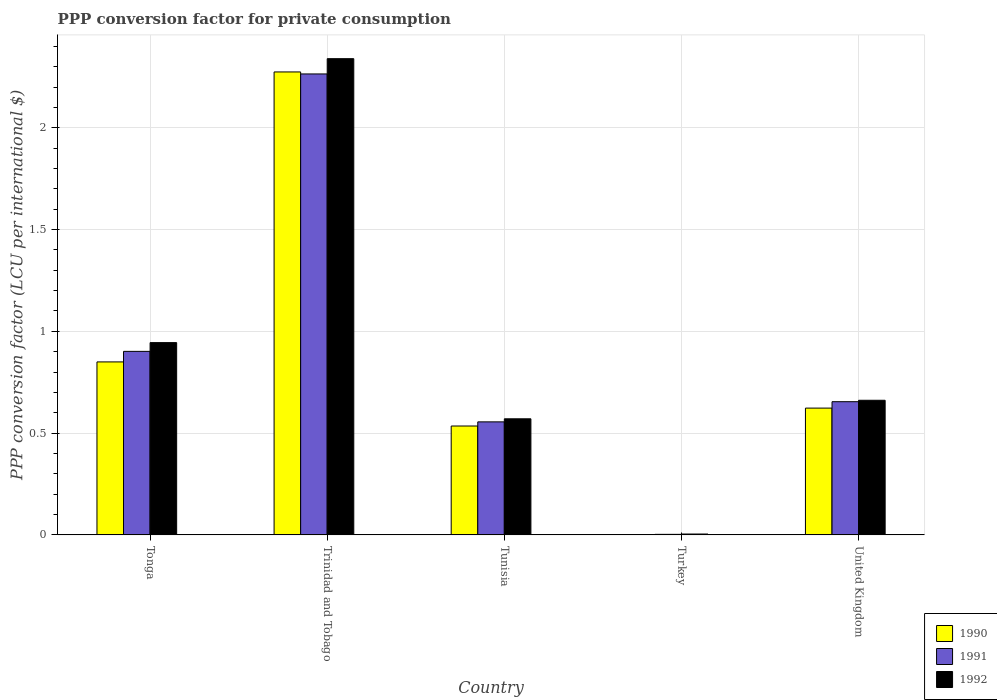How many groups of bars are there?
Your response must be concise. 5. Are the number of bars per tick equal to the number of legend labels?
Ensure brevity in your answer.  Yes. How many bars are there on the 3rd tick from the right?
Your answer should be very brief. 3. What is the label of the 2nd group of bars from the left?
Offer a very short reply. Trinidad and Tobago. In how many cases, is the number of bars for a given country not equal to the number of legend labels?
Offer a very short reply. 0. What is the PPP conversion factor for private consumption in 1991 in Trinidad and Tobago?
Make the answer very short. 2.26. Across all countries, what is the maximum PPP conversion factor for private consumption in 1990?
Your answer should be very brief. 2.27. Across all countries, what is the minimum PPP conversion factor for private consumption in 1990?
Offer a very short reply. 0. In which country was the PPP conversion factor for private consumption in 1992 maximum?
Your answer should be very brief. Trinidad and Tobago. What is the total PPP conversion factor for private consumption in 1991 in the graph?
Your response must be concise. 4.38. What is the difference between the PPP conversion factor for private consumption in 1991 in Tunisia and that in United Kingdom?
Your response must be concise. -0.1. What is the difference between the PPP conversion factor for private consumption in 1992 in United Kingdom and the PPP conversion factor for private consumption in 1991 in Trinidad and Tobago?
Make the answer very short. -1.6. What is the average PPP conversion factor for private consumption in 1992 per country?
Offer a terse response. 0.9. What is the difference between the PPP conversion factor for private consumption of/in 1990 and PPP conversion factor for private consumption of/in 1992 in Turkey?
Offer a very short reply. -0. What is the ratio of the PPP conversion factor for private consumption in 1990 in Trinidad and Tobago to that in Tunisia?
Offer a terse response. 4.25. What is the difference between the highest and the second highest PPP conversion factor for private consumption in 1992?
Give a very brief answer. 0.28. What is the difference between the highest and the lowest PPP conversion factor for private consumption in 1990?
Offer a terse response. 2.27. What does the 1st bar from the right in Trinidad and Tobago represents?
Offer a terse response. 1992. Is it the case that in every country, the sum of the PPP conversion factor for private consumption in 1991 and PPP conversion factor for private consumption in 1990 is greater than the PPP conversion factor for private consumption in 1992?
Keep it short and to the point. Yes. How many bars are there?
Offer a very short reply. 15. Does the graph contain any zero values?
Make the answer very short. No. Does the graph contain grids?
Offer a very short reply. Yes. How are the legend labels stacked?
Ensure brevity in your answer.  Vertical. What is the title of the graph?
Your response must be concise. PPP conversion factor for private consumption. Does "1970" appear as one of the legend labels in the graph?
Provide a succinct answer. No. What is the label or title of the Y-axis?
Keep it short and to the point. PPP conversion factor (LCU per international $). What is the PPP conversion factor (LCU per international $) in 1990 in Tonga?
Your response must be concise. 0.85. What is the PPP conversion factor (LCU per international $) in 1991 in Tonga?
Offer a terse response. 0.9. What is the PPP conversion factor (LCU per international $) of 1992 in Tonga?
Your answer should be compact. 0.94. What is the PPP conversion factor (LCU per international $) in 1990 in Trinidad and Tobago?
Give a very brief answer. 2.27. What is the PPP conversion factor (LCU per international $) in 1991 in Trinidad and Tobago?
Provide a succinct answer. 2.26. What is the PPP conversion factor (LCU per international $) in 1992 in Trinidad and Tobago?
Your answer should be very brief. 2.34. What is the PPP conversion factor (LCU per international $) of 1990 in Tunisia?
Make the answer very short. 0.53. What is the PPP conversion factor (LCU per international $) of 1991 in Tunisia?
Offer a terse response. 0.56. What is the PPP conversion factor (LCU per international $) of 1992 in Tunisia?
Provide a succinct answer. 0.57. What is the PPP conversion factor (LCU per international $) in 1990 in Turkey?
Offer a very short reply. 0. What is the PPP conversion factor (LCU per international $) in 1991 in Turkey?
Offer a very short reply. 0. What is the PPP conversion factor (LCU per international $) of 1992 in Turkey?
Offer a very short reply. 0. What is the PPP conversion factor (LCU per international $) of 1990 in United Kingdom?
Offer a terse response. 0.62. What is the PPP conversion factor (LCU per international $) of 1991 in United Kingdom?
Offer a terse response. 0.65. What is the PPP conversion factor (LCU per international $) in 1992 in United Kingdom?
Ensure brevity in your answer.  0.66. Across all countries, what is the maximum PPP conversion factor (LCU per international $) in 1990?
Your answer should be very brief. 2.27. Across all countries, what is the maximum PPP conversion factor (LCU per international $) of 1991?
Ensure brevity in your answer.  2.26. Across all countries, what is the maximum PPP conversion factor (LCU per international $) of 1992?
Provide a short and direct response. 2.34. Across all countries, what is the minimum PPP conversion factor (LCU per international $) of 1990?
Offer a very short reply. 0. Across all countries, what is the minimum PPP conversion factor (LCU per international $) of 1991?
Your answer should be compact. 0. Across all countries, what is the minimum PPP conversion factor (LCU per international $) of 1992?
Provide a short and direct response. 0. What is the total PPP conversion factor (LCU per international $) of 1990 in the graph?
Provide a short and direct response. 4.28. What is the total PPP conversion factor (LCU per international $) of 1991 in the graph?
Keep it short and to the point. 4.38. What is the total PPP conversion factor (LCU per international $) in 1992 in the graph?
Your answer should be very brief. 4.52. What is the difference between the PPP conversion factor (LCU per international $) in 1990 in Tonga and that in Trinidad and Tobago?
Offer a very short reply. -1.42. What is the difference between the PPP conversion factor (LCU per international $) in 1991 in Tonga and that in Trinidad and Tobago?
Provide a succinct answer. -1.36. What is the difference between the PPP conversion factor (LCU per international $) of 1992 in Tonga and that in Trinidad and Tobago?
Provide a succinct answer. -1.39. What is the difference between the PPP conversion factor (LCU per international $) in 1990 in Tonga and that in Tunisia?
Provide a succinct answer. 0.31. What is the difference between the PPP conversion factor (LCU per international $) of 1991 in Tonga and that in Tunisia?
Make the answer very short. 0.35. What is the difference between the PPP conversion factor (LCU per international $) in 1992 in Tonga and that in Tunisia?
Offer a very short reply. 0.37. What is the difference between the PPP conversion factor (LCU per international $) in 1990 in Tonga and that in Turkey?
Provide a short and direct response. 0.85. What is the difference between the PPP conversion factor (LCU per international $) in 1991 in Tonga and that in Turkey?
Your response must be concise. 0.9. What is the difference between the PPP conversion factor (LCU per international $) in 1992 in Tonga and that in Turkey?
Offer a very short reply. 0.94. What is the difference between the PPP conversion factor (LCU per international $) of 1990 in Tonga and that in United Kingdom?
Offer a very short reply. 0.23. What is the difference between the PPP conversion factor (LCU per international $) in 1991 in Tonga and that in United Kingdom?
Make the answer very short. 0.25. What is the difference between the PPP conversion factor (LCU per international $) of 1992 in Tonga and that in United Kingdom?
Make the answer very short. 0.28. What is the difference between the PPP conversion factor (LCU per international $) in 1990 in Trinidad and Tobago and that in Tunisia?
Provide a short and direct response. 1.74. What is the difference between the PPP conversion factor (LCU per international $) in 1991 in Trinidad and Tobago and that in Tunisia?
Your answer should be very brief. 1.71. What is the difference between the PPP conversion factor (LCU per international $) in 1992 in Trinidad and Tobago and that in Tunisia?
Ensure brevity in your answer.  1.77. What is the difference between the PPP conversion factor (LCU per international $) in 1990 in Trinidad and Tobago and that in Turkey?
Keep it short and to the point. 2.27. What is the difference between the PPP conversion factor (LCU per international $) of 1991 in Trinidad and Tobago and that in Turkey?
Ensure brevity in your answer.  2.26. What is the difference between the PPP conversion factor (LCU per international $) in 1992 in Trinidad and Tobago and that in Turkey?
Provide a succinct answer. 2.33. What is the difference between the PPP conversion factor (LCU per international $) in 1990 in Trinidad and Tobago and that in United Kingdom?
Provide a succinct answer. 1.65. What is the difference between the PPP conversion factor (LCU per international $) of 1991 in Trinidad and Tobago and that in United Kingdom?
Ensure brevity in your answer.  1.61. What is the difference between the PPP conversion factor (LCU per international $) of 1992 in Trinidad and Tobago and that in United Kingdom?
Keep it short and to the point. 1.68. What is the difference between the PPP conversion factor (LCU per international $) in 1990 in Tunisia and that in Turkey?
Your response must be concise. 0.53. What is the difference between the PPP conversion factor (LCU per international $) of 1991 in Tunisia and that in Turkey?
Make the answer very short. 0.55. What is the difference between the PPP conversion factor (LCU per international $) of 1992 in Tunisia and that in Turkey?
Ensure brevity in your answer.  0.57. What is the difference between the PPP conversion factor (LCU per international $) of 1990 in Tunisia and that in United Kingdom?
Provide a succinct answer. -0.09. What is the difference between the PPP conversion factor (LCU per international $) of 1991 in Tunisia and that in United Kingdom?
Provide a succinct answer. -0.1. What is the difference between the PPP conversion factor (LCU per international $) of 1992 in Tunisia and that in United Kingdom?
Provide a short and direct response. -0.09. What is the difference between the PPP conversion factor (LCU per international $) in 1990 in Turkey and that in United Kingdom?
Give a very brief answer. -0.62. What is the difference between the PPP conversion factor (LCU per international $) in 1991 in Turkey and that in United Kingdom?
Your response must be concise. -0.65. What is the difference between the PPP conversion factor (LCU per international $) of 1992 in Turkey and that in United Kingdom?
Your answer should be very brief. -0.66. What is the difference between the PPP conversion factor (LCU per international $) in 1990 in Tonga and the PPP conversion factor (LCU per international $) in 1991 in Trinidad and Tobago?
Your answer should be compact. -1.41. What is the difference between the PPP conversion factor (LCU per international $) in 1990 in Tonga and the PPP conversion factor (LCU per international $) in 1992 in Trinidad and Tobago?
Provide a short and direct response. -1.49. What is the difference between the PPP conversion factor (LCU per international $) in 1991 in Tonga and the PPP conversion factor (LCU per international $) in 1992 in Trinidad and Tobago?
Provide a short and direct response. -1.44. What is the difference between the PPP conversion factor (LCU per international $) in 1990 in Tonga and the PPP conversion factor (LCU per international $) in 1991 in Tunisia?
Your response must be concise. 0.29. What is the difference between the PPP conversion factor (LCU per international $) of 1990 in Tonga and the PPP conversion factor (LCU per international $) of 1992 in Tunisia?
Your response must be concise. 0.28. What is the difference between the PPP conversion factor (LCU per international $) in 1991 in Tonga and the PPP conversion factor (LCU per international $) in 1992 in Tunisia?
Give a very brief answer. 0.33. What is the difference between the PPP conversion factor (LCU per international $) in 1990 in Tonga and the PPP conversion factor (LCU per international $) in 1991 in Turkey?
Make the answer very short. 0.85. What is the difference between the PPP conversion factor (LCU per international $) in 1990 in Tonga and the PPP conversion factor (LCU per international $) in 1992 in Turkey?
Your response must be concise. 0.85. What is the difference between the PPP conversion factor (LCU per international $) in 1991 in Tonga and the PPP conversion factor (LCU per international $) in 1992 in Turkey?
Ensure brevity in your answer.  0.9. What is the difference between the PPP conversion factor (LCU per international $) in 1990 in Tonga and the PPP conversion factor (LCU per international $) in 1991 in United Kingdom?
Ensure brevity in your answer.  0.2. What is the difference between the PPP conversion factor (LCU per international $) in 1990 in Tonga and the PPP conversion factor (LCU per international $) in 1992 in United Kingdom?
Your answer should be compact. 0.19. What is the difference between the PPP conversion factor (LCU per international $) of 1991 in Tonga and the PPP conversion factor (LCU per international $) of 1992 in United Kingdom?
Your answer should be very brief. 0.24. What is the difference between the PPP conversion factor (LCU per international $) of 1990 in Trinidad and Tobago and the PPP conversion factor (LCU per international $) of 1991 in Tunisia?
Offer a very short reply. 1.72. What is the difference between the PPP conversion factor (LCU per international $) in 1990 in Trinidad and Tobago and the PPP conversion factor (LCU per international $) in 1992 in Tunisia?
Ensure brevity in your answer.  1.7. What is the difference between the PPP conversion factor (LCU per international $) of 1991 in Trinidad and Tobago and the PPP conversion factor (LCU per international $) of 1992 in Tunisia?
Make the answer very short. 1.69. What is the difference between the PPP conversion factor (LCU per international $) in 1990 in Trinidad and Tobago and the PPP conversion factor (LCU per international $) in 1991 in Turkey?
Offer a very short reply. 2.27. What is the difference between the PPP conversion factor (LCU per international $) in 1990 in Trinidad and Tobago and the PPP conversion factor (LCU per international $) in 1992 in Turkey?
Provide a short and direct response. 2.27. What is the difference between the PPP conversion factor (LCU per international $) in 1991 in Trinidad and Tobago and the PPP conversion factor (LCU per international $) in 1992 in Turkey?
Give a very brief answer. 2.26. What is the difference between the PPP conversion factor (LCU per international $) in 1990 in Trinidad and Tobago and the PPP conversion factor (LCU per international $) in 1991 in United Kingdom?
Your response must be concise. 1.62. What is the difference between the PPP conversion factor (LCU per international $) in 1990 in Trinidad and Tobago and the PPP conversion factor (LCU per international $) in 1992 in United Kingdom?
Provide a short and direct response. 1.61. What is the difference between the PPP conversion factor (LCU per international $) in 1991 in Trinidad and Tobago and the PPP conversion factor (LCU per international $) in 1992 in United Kingdom?
Offer a terse response. 1.6. What is the difference between the PPP conversion factor (LCU per international $) of 1990 in Tunisia and the PPP conversion factor (LCU per international $) of 1991 in Turkey?
Give a very brief answer. 0.53. What is the difference between the PPP conversion factor (LCU per international $) of 1990 in Tunisia and the PPP conversion factor (LCU per international $) of 1992 in Turkey?
Make the answer very short. 0.53. What is the difference between the PPP conversion factor (LCU per international $) in 1991 in Tunisia and the PPP conversion factor (LCU per international $) in 1992 in Turkey?
Provide a succinct answer. 0.55. What is the difference between the PPP conversion factor (LCU per international $) of 1990 in Tunisia and the PPP conversion factor (LCU per international $) of 1991 in United Kingdom?
Give a very brief answer. -0.12. What is the difference between the PPP conversion factor (LCU per international $) of 1990 in Tunisia and the PPP conversion factor (LCU per international $) of 1992 in United Kingdom?
Your answer should be very brief. -0.13. What is the difference between the PPP conversion factor (LCU per international $) in 1991 in Tunisia and the PPP conversion factor (LCU per international $) in 1992 in United Kingdom?
Offer a terse response. -0.11. What is the difference between the PPP conversion factor (LCU per international $) of 1990 in Turkey and the PPP conversion factor (LCU per international $) of 1991 in United Kingdom?
Ensure brevity in your answer.  -0.65. What is the difference between the PPP conversion factor (LCU per international $) of 1990 in Turkey and the PPP conversion factor (LCU per international $) of 1992 in United Kingdom?
Provide a succinct answer. -0.66. What is the difference between the PPP conversion factor (LCU per international $) in 1991 in Turkey and the PPP conversion factor (LCU per international $) in 1992 in United Kingdom?
Your answer should be compact. -0.66. What is the average PPP conversion factor (LCU per international $) of 1990 per country?
Your answer should be very brief. 0.86. What is the average PPP conversion factor (LCU per international $) in 1991 per country?
Your answer should be compact. 0.88. What is the average PPP conversion factor (LCU per international $) of 1992 per country?
Keep it short and to the point. 0.9. What is the difference between the PPP conversion factor (LCU per international $) in 1990 and PPP conversion factor (LCU per international $) in 1991 in Tonga?
Offer a very short reply. -0.05. What is the difference between the PPP conversion factor (LCU per international $) of 1990 and PPP conversion factor (LCU per international $) of 1992 in Tonga?
Make the answer very short. -0.09. What is the difference between the PPP conversion factor (LCU per international $) of 1991 and PPP conversion factor (LCU per international $) of 1992 in Tonga?
Make the answer very short. -0.04. What is the difference between the PPP conversion factor (LCU per international $) of 1990 and PPP conversion factor (LCU per international $) of 1991 in Trinidad and Tobago?
Your answer should be very brief. 0.01. What is the difference between the PPP conversion factor (LCU per international $) in 1990 and PPP conversion factor (LCU per international $) in 1992 in Trinidad and Tobago?
Your answer should be compact. -0.07. What is the difference between the PPP conversion factor (LCU per international $) of 1991 and PPP conversion factor (LCU per international $) of 1992 in Trinidad and Tobago?
Provide a short and direct response. -0.07. What is the difference between the PPP conversion factor (LCU per international $) in 1990 and PPP conversion factor (LCU per international $) in 1991 in Tunisia?
Ensure brevity in your answer.  -0.02. What is the difference between the PPP conversion factor (LCU per international $) in 1990 and PPP conversion factor (LCU per international $) in 1992 in Tunisia?
Offer a very short reply. -0.04. What is the difference between the PPP conversion factor (LCU per international $) of 1991 and PPP conversion factor (LCU per international $) of 1992 in Tunisia?
Provide a succinct answer. -0.02. What is the difference between the PPP conversion factor (LCU per international $) of 1990 and PPP conversion factor (LCU per international $) of 1991 in Turkey?
Your response must be concise. -0. What is the difference between the PPP conversion factor (LCU per international $) of 1990 and PPP conversion factor (LCU per international $) of 1992 in Turkey?
Your response must be concise. -0. What is the difference between the PPP conversion factor (LCU per international $) in 1991 and PPP conversion factor (LCU per international $) in 1992 in Turkey?
Your answer should be very brief. -0. What is the difference between the PPP conversion factor (LCU per international $) of 1990 and PPP conversion factor (LCU per international $) of 1991 in United Kingdom?
Provide a short and direct response. -0.03. What is the difference between the PPP conversion factor (LCU per international $) in 1990 and PPP conversion factor (LCU per international $) in 1992 in United Kingdom?
Offer a terse response. -0.04. What is the difference between the PPP conversion factor (LCU per international $) of 1991 and PPP conversion factor (LCU per international $) of 1992 in United Kingdom?
Your answer should be compact. -0.01. What is the ratio of the PPP conversion factor (LCU per international $) of 1990 in Tonga to that in Trinidad and Tobago?
Offer a very short reply. 0.37. What is the ratio of the PPP conversion factor (LCU per international $) of 1991 in Tonga to that in Trinidad and Tobago?
Ensure brevity in your answer.  0.4. What is the ratio of the PPP conversion factor (LCU per international $) in 1992 in Tonga to that in Trinidad and Tobago?
Make the answer very short. 0.4. What is the ratio of the PPP conversion factor (LCU per international $) of 1990 in Tonga to that in Tunisia?
Offer a terse response. 1.59. What is the ratio of the PPP conversion factor (LCU per international $) in 1991 in Tonga to that in Tunisia?
Give a very brief answer. 1.62. What is the ratio of the PPP conversion factor (LCU per international $) of 1992 in Tonga to that in Tunisia?
Offer a very short reply. 1.66. What is the ratio of the PPP conversion factor (LCU per international $) of 1990 in Tonga to that in Turkey?
Provide a short and direct response. 496.9. What is the ratio of the PPP conversion factor (LCU per international $) in 1991 in Tonga to that in Turkey?
Make the answer very short. 338.8. What is the ratio of the PPP conversion factor (LCU per international $) in 1992 in Tonga to that in Turkey?
Provide a succinct answer. 220.11. What is the ratio of the PPP conversion factor (LCU per international $) of 1990 in Tonga to that in United Kingdom?
Offer a terse response. 1.36. What is the ratio of the PPP conversion factor (LCU per international $) of 1991 in Tonga to that in United Kingdom?
Make the answer very short. 1.38. What is the ratio of the PPP conversion factor (LCU per international $) in 1992 in Tonga to that in United Kingdom?
Provide a succinct answer. 1.43. What is the ratio of the PPP conversion factor (LCU per international $) in 1990 in Trinidad and Tobago to that in Tunisia?
Keep it short and to the point. 4.25. What is the ratio of the PPP conversion factor (LCU per international $) in 1991 in Trinidad and Tobago to that in Tunisia?
Provide a succinct answer. 4.08. What is the ratio of the PPP conversion factor (LCU per international $) in 1992 in Trinidad and Tobago to that in Tunisia?
Your answer should be very brief. 4.1. What is the ratio of the PPP conversion factor (LCU per international $) of 1990 in Trinidad and Tobago to that in Turkey?
Offer a very short reply. 1329.9. What is the ratio of the PPP conversion factor (LCU per international $) in 1991 in Trinidad and Tobago to that in Turkey?
Give a very brief answer. 850.91. What is the ratio of the PPP conversion factor (LCU per international $) of 1992 in Trinidad and Tobago to that in Turkey?
Your answer should be compact. 545.15. What is the ratio of the PPP conversion factor (LCU per international $) of 1990 in Trinidad and Tobago to that in United Kingdom?
Offer a terse response. 3.65. What is the ratio of the PPP conversion factor (LCU per international $) in 1991 in Trinidad and Tobago to that in United Kingdom?
Keep it short and to the point. 3.46. What is the ratio of the PPP conversion factor (LCU per international $) of 1992 in Trinidad and Tobago to that in United Kingdom?
Offer a very short reply. 3.54. What is the ratio of the PPP conversion factor (LCU per international $) of 1990 in Tunisia to that in Turkey?
Ensure brevity in your answer.  312.81. What is the ratio of the PPP conversion factor (LCU per international $) in 1991 in Tunisia to that in Turkey?
Your response must be concise. 208.65. What is the ratio of the PPP conversion factor (LCU per international $) of 1992 in Tunisia to that in Turkey?
Give a very brief answer. 132.9. What is the ratio of the PPP conversion factor (LCU per international $) in 1990 in Tunisia to that in United Kingdom?
Provide a succinct answer. 0.86. What is the ratio of the PPP conversion factor (LCU per international $) of 1991 in Tunisia to that in United Kingdom?
Keep it short and to the point. 0.85. What is the ratio of the PPP conversion factor (LCU per international $) in 1992 in Tunisia to that in United Kingdom?
Offer a very short reply. 0.86. What is the ratio of the PPP conversion factor (LCU per international $) of 1990 in Turkey to that in United Kingdom?
Offer a terse response. 0. What is the ratio of the PPP conversion factor (LCU per international $) in 1991 in Turkey to that in United Kingdom?
Your answer should be compact. 0. What is the ratio of the PPP conversion factor (LCU per international $) in 1992 in Turkey to that in United Kingdom?
Offer a very short reply. 0.01. What is the difference between the highest and the second highest PPP conversion factor (LCU per international $) of 1990?
Offer a very short reply. 1.42. What is the difference between the highest and the second highest PPP conversion factor (LCU per international $) of 1991?
Your answer should be very brief. 1.36. What is the difference between the highest and the second highest PPP conversion factor (LCU per international $) in 1992?
Provide a short and direct response. 1.39. What is the difference between the highest and the lowest PPP conversion factor (LCU per international $) of 1990?
Keep it short and to the point. 2.27. What is the difference between the highest and the lowest PPP conversion factor (LCU per international $) of 1991?
Give a very brief answer. 2.26. What is the difference between the highest and the lowest PPP conversion factor (LCU per international $) in 1992?
Your answer should be compact. 2.33. 